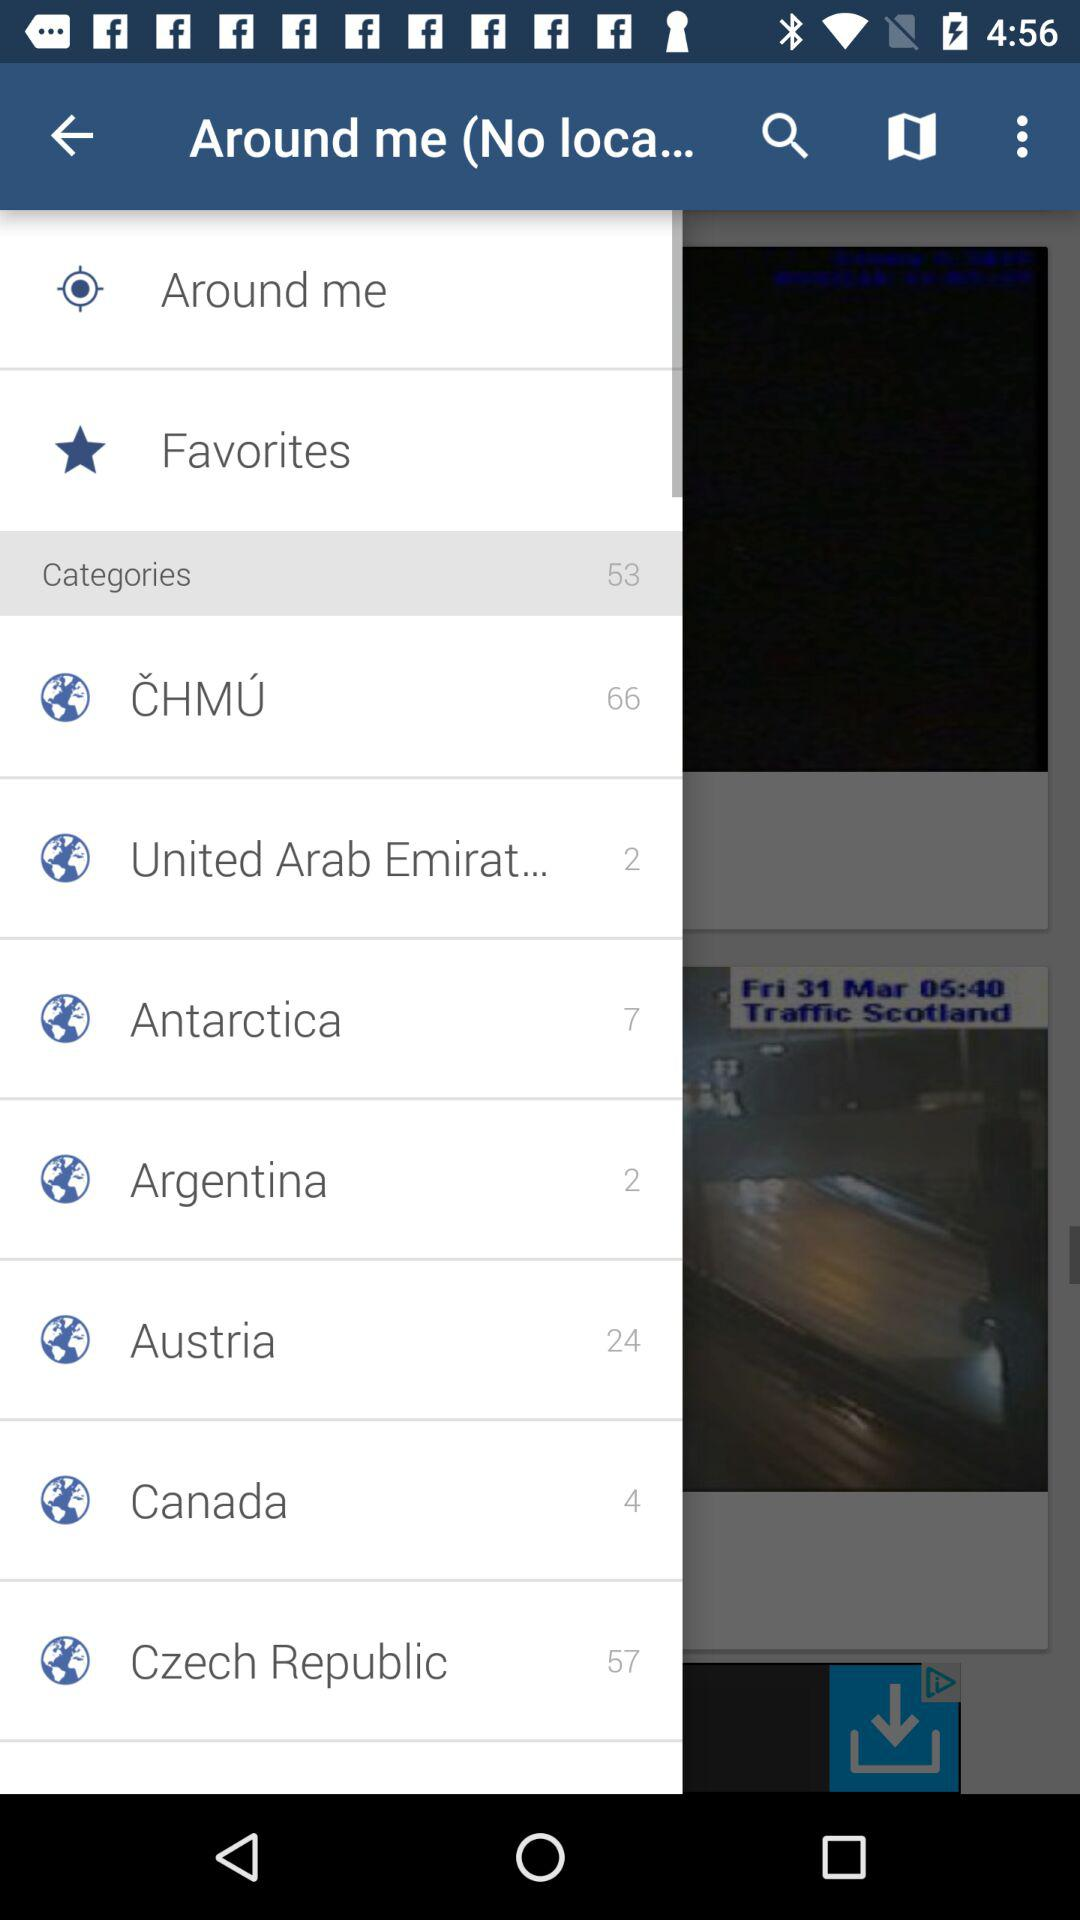How many categories are in Canada? There are 4 categories. 